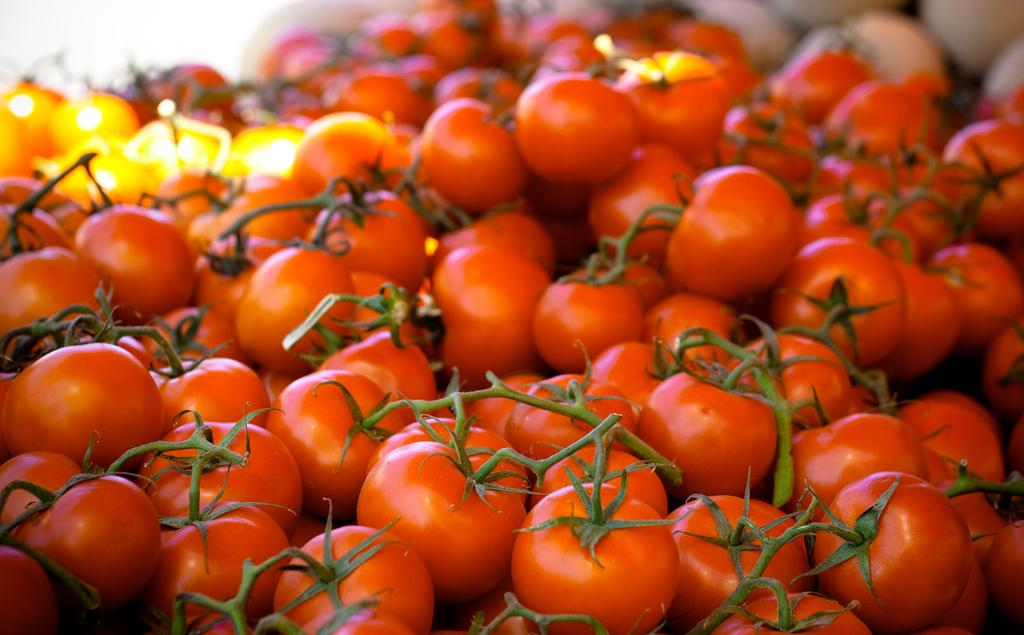What is the main subject of the image? The main subject of the image is a group of tomatoes. Can you describe the background of the image? The background of the image is blurred. What type of car can be seen driving through the tomatoes in the image? There is no car present in the image; it features a group of tomatoes with a blurred background. 